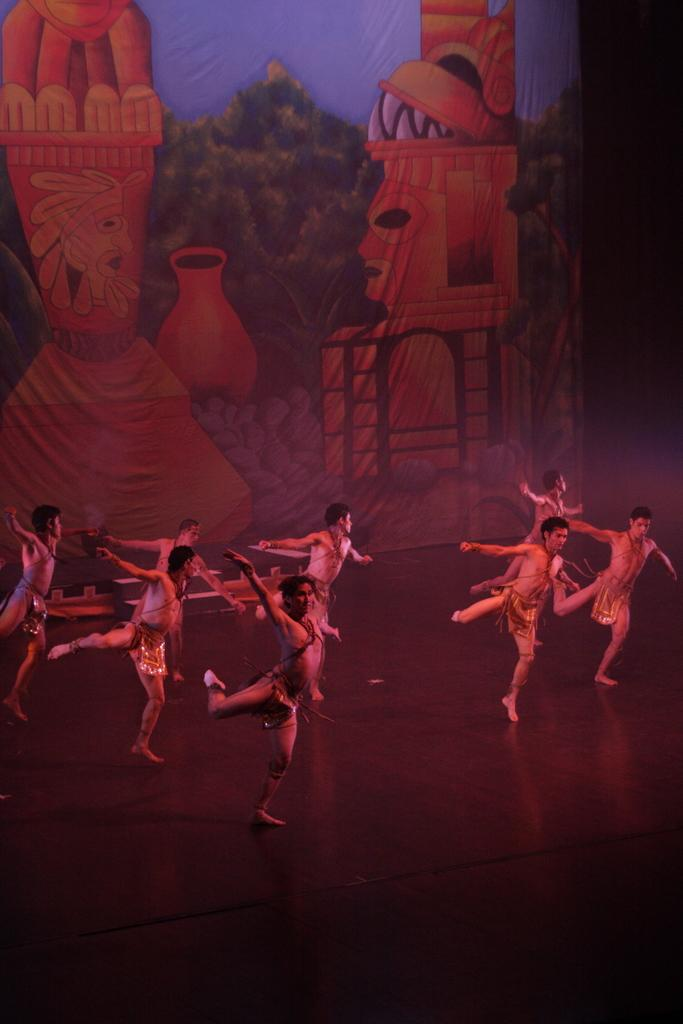Who or what can be seen in the image? There are people in the image. What are the people wearing? The people are wearing costumes. Where are the people performing? The people are performing on a dais. What is visible in the background of the image? There is a curtain in the background of the image. What type of beam is holding up the branch in the image? There is no beam or branch present in the image; it features people wearing costumes and performing on a dais. What flavor of toothpaste is being used by the people in the image? There is no toothpaste present in the image; it features people wearing costumes and performing on a dais. 